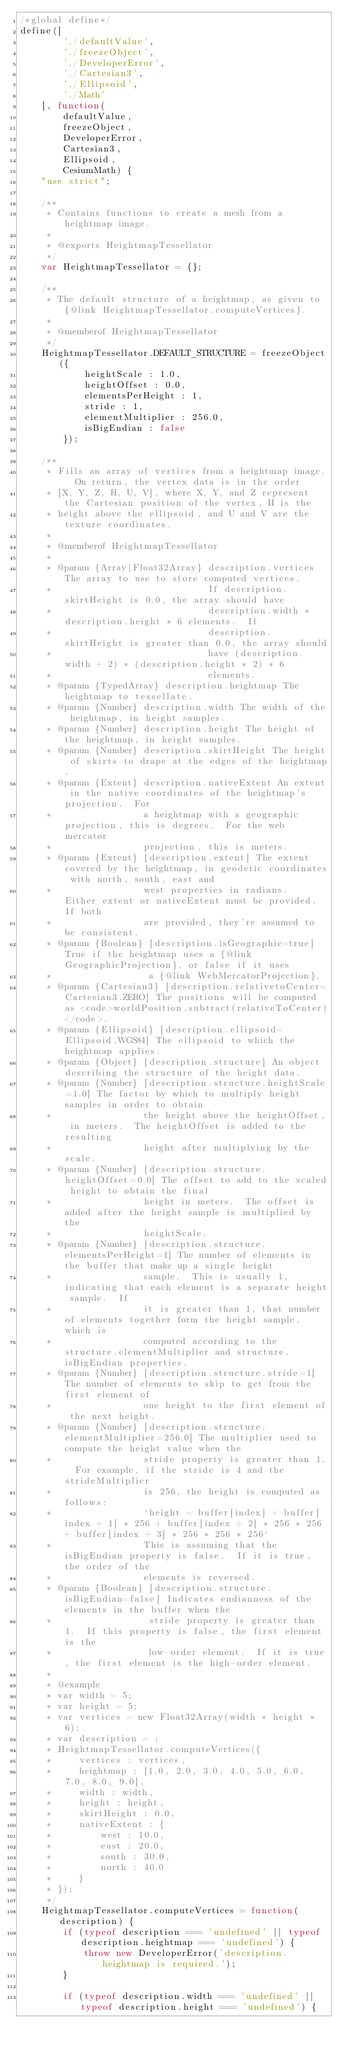Convert code to text. <code><loc_0><loc_0><loc_500><loc_500><_JavaScript_>/*global define*/
define([
        './defaultValue',
        './freezeObject',
        './DeveloperError',
        './Cartesian3',
        './Ellipsoid',
        './Math'
    ], function(
        defaultValue,
        freezeObject,
        DeveloperError,
        Cartesian3,
        Ellipsoid,
        CesiumMath) {
    "use strict";

    /**
     * Contains functions to create a mesh from a heightmap image.
     *
     * @exports HeightmapTessellator
     */
    var HeightmapTessellator = {};

    /**
     * The default structure of a heightmap, as given to {@link HeightmapTessellator.computeVertices}.
     *
     * @memberof HeightmapTessellator
     */
    HeightmapTessellator.DEFAULT_STRUCTURE = freezeObject({
            heightScale : 1.0,
            heightOffset : 0.0,
            elementsPerHeight : 1,
            stride : 1,
            elementMultiplier : 256.0,
            isBigEndian : false
        });

    /**
     * Fills an array of vertices from a heightmap image.  On return, the vertex data is in the order
     * [X, Y, Z, H, U, V], where X, Y, and Z represent the Cartesian position of the vertex, H is the
     * height above the ellipsoid, and U and V are the texture coordinates.
     *
     * @memberof HeightmapTessellator
     *
     * @param {Array|Float32Array} description.vertices The array to use to store computed vertices.
     *                             If description.skirtHeight is 0.0, the array should have
     *                             description.width * description.height * 6 elements.  If
     *                             description.skirtHeight is greater than 0.0, the array should
     *                             have (description.width + 2) * (description.height * 2) * 6
     *                             elements.
     * @param {TypedArray} description.heightmap The heightmap to tessellate.
     * @param {Number} description.width The width of the heightmap, in height samples.
     * @param {Number} description.height The height of the heightmap, in height samples.
     * @param {Number} description.skirtHeight The height of skirts to drape at the edges of the heightmap.
     * @param {Extent} description.nativeExtent An extent in the native coordinates of the heightmap's projection.  For
     *                 a heightmap with a geographic projection, this is degrees.  For the web mercator
     *                 projection, this is meters.
     * @param {Extent} [description.extent] The extent covered by the heightmap, in geodetic coordinates with north, south, east and
     *                 west properties in radians.  Either extent or nativeExtent must be provided.  If both
     *                 are provided, they're assumed to be consistent.
     * @param {Boolean} [description.isGeographic=true] True if the heightmap uses a {@link GeographicProjection}, or false if it uses
     *                  a {@link WebMercatorProjection}.
     * @param {Cartesian3} [description.relativetoCenter=Cartesian3.ZERO] The positions will be computed as <code>worldPosition.subtract(relativeToCenter)</code>.
     * @param {Ellipsoid} [description.ellipsoid=Ellipsoid.WGS84] The ellipsoid to which the heightmap applies.
     * @param {Object} [description.structure] An object describing the structure of the height data.
     * @param {Number} [description.structure.heightScale=1.0] The factor by which to multiply height samples in order to obtain
     *                 the height above the heightOffset, in meters.  The heightOffset is added to the resulting
     *                 height after multiplying by the scale.
     * @param {Number} [description.structure.heightOffset=0.0] The offset to add to the scaled height to obtain the final
     *                 height in meters.  The offset is added after the height sample is multiplied by the
     *                 heightScale.
     * @param {Number} [description.structure.elementsPerHeight=1] The number of elements in the buffer that make up a single height
     *                 sample.  This is usually 1, indicating that each element is a separate height sample.  If
     *                 it is greater than 1, that number of elements together form the height sample, which is
     *                 computed according to the structure.elementMultiplier and structure.isBigEndian properties.
     * @param {Number} [description.structure.stride=1] The number of elements to skip to get from the first element of
     *                 one height to the first element of the next height.
     * @param {Number} [description.structure.elementMultiplier=256.0] The multiplier used to compute the height value when the
     *                 stride property is greater than 1.  For example, if the stride is 4 and the strideMultiplier
     *                 is 256, the height is computed as follows:
     *                 `height = buffer[index] + buffer[index + 1] * 256 + buffer[index + 2] * 256 * 256 + buffer[index + 3] * 256 * 256 * 256`
     *                 This is assuming that the isBigEndian property is false.  If it is true, the order of the
     *                 elements is reversed.
     * @param {Boolean} [description.structure.isBigEndian=false] Indicates endianness of the elements in the buffer when the
     *                  stride property is greater than 1.  If this property is false, the first element is the
     *                  low-order element.  If it is true, the first element is the high-order element.
     *
     * @example
     * var width = 5;
     * var height = 5;
     * var vertices = new Float32Array(width * height * 6);
     * var description = ;
     * HeightmapTessellator.computeVertices({
     *     vertices : vertices,
     *     heightmap : [1.0, 2.0, 3.0, 4.0, 5.0, 6.0, 7.0, 8.0, 9.0],
     *     width : width,
     *     height : height,
     *     skirtHeight : 0.0,
     *     nativeExtent : {
     *         west : 10.0,
     *         east : 20.0,
     *         south : 30.0,
     *         north : 40.0
     *     }
     * });
     */
    HeightmapTessellator.computeVertices = function(description) {
        if (typeof description === 'undefined' || typeof description.heightmap === 'undefined') {
            throw new DeveloperError('description.heightmap is required.');
        }

        if (typeof description.width === 'undefined' || typeof description.height === 'undefined') {</code> 